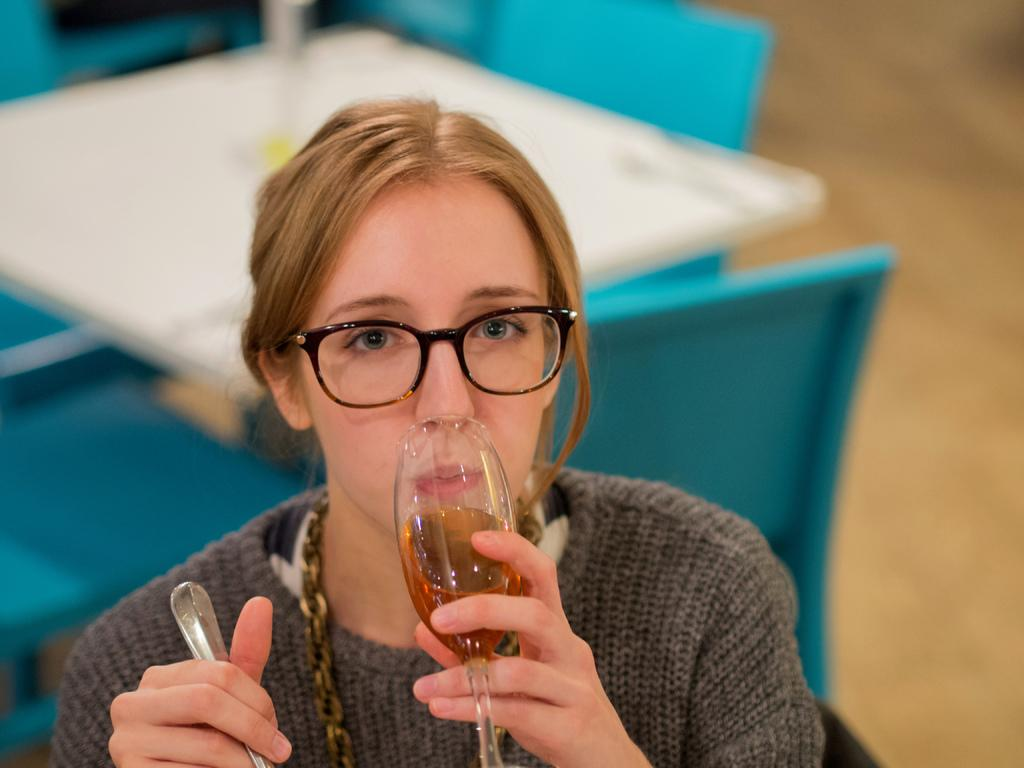Who is the main subject in the image? There is a woman in the image. What is the woman doing in the image? The woman is drinking from a glass and holding a spoon. What type of curve can be seen on the toad's back in the image? There is no toad present in the image, so there is no curve to be seen on its back. 